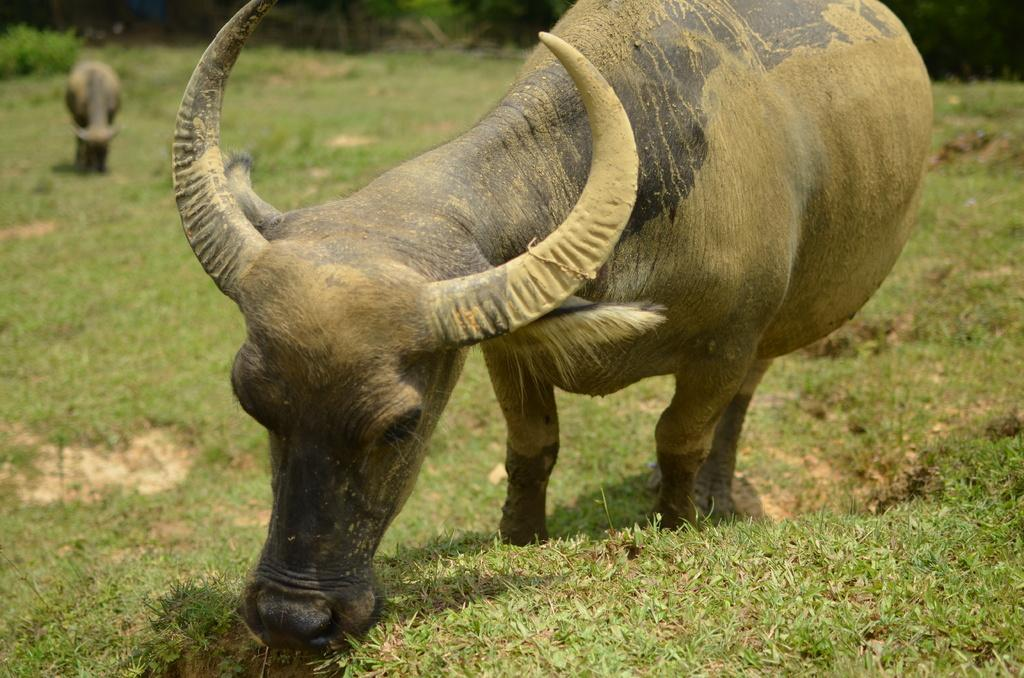What animals can be seen in the image? There are two buffaloes in the image. What are the buffaloes doing in the image? The buffaloes are eating grass. Can you describe the background of the image? The background of the image is blurred. What holiday is being celebrated by the buffaloes in the image? There is no indication of a holiday being celebrated in the image; it simply shows two buffaloes eating grass. What arithmetic problem can be solved using the buffaloes in the image? There is no arithmetic problem present in the image, as it only features two buffaloes eating grass. 